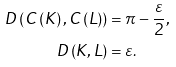<formula> <loc_0><loc_0><loc_500><loc_500>D \left ( C \left ( K \right ) , C \left ( L \right ) \right ) & = \pi - \frac { \varepsilon } { 2 } , \\ D \left ( K , L \right ) & = \varepsilon .</formula> 